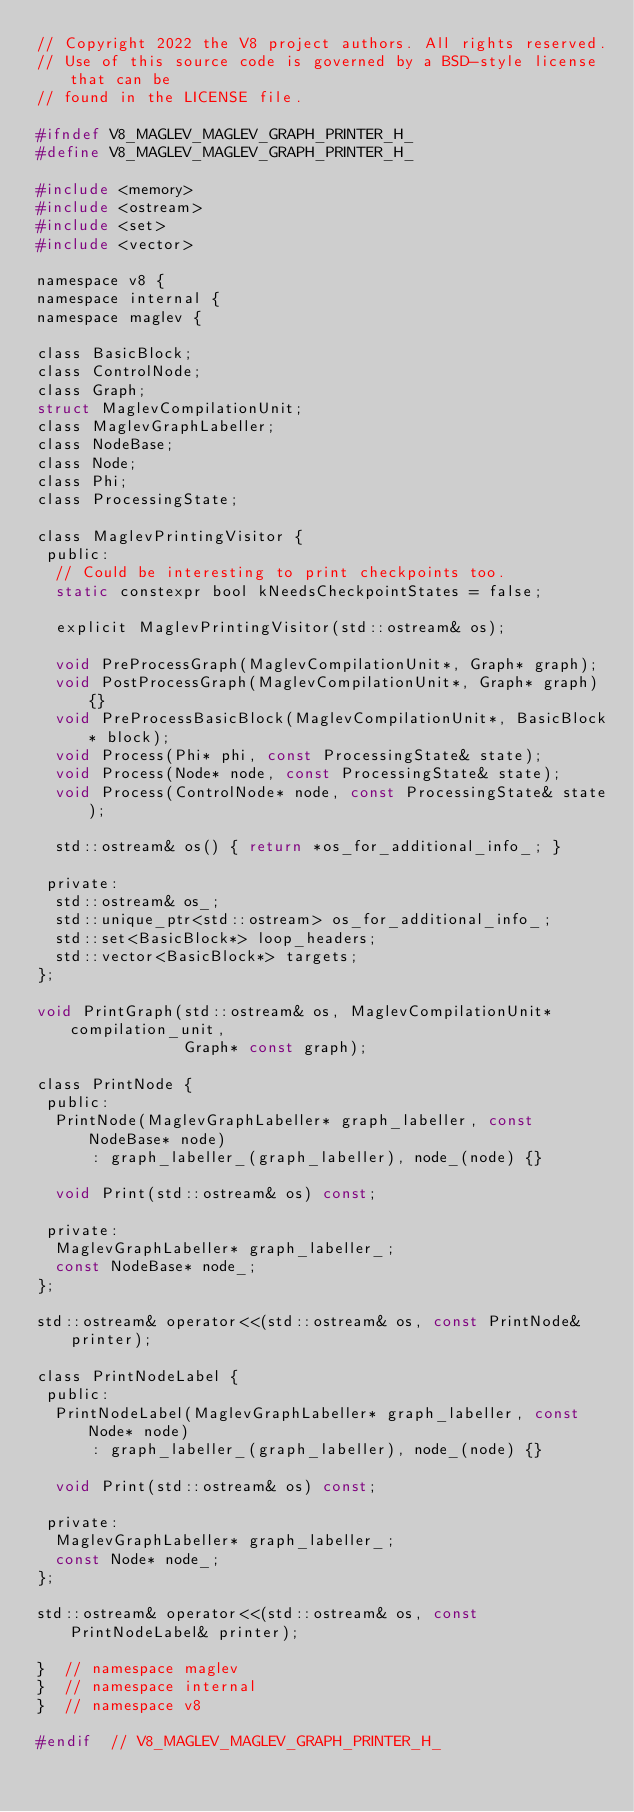<code> <loc_0><loc_0><loc_500><loc_500><_C_>// Copyright 2022 the V8 project authors. All rights reserved.
// Use of this source code is governed by a BSD-style license that can be
// found in the LICENSE file.

#ifndef V8_MAGLEV_MAGLEV_GRAPH_PRINTER_H_
#define V8_MAGLEV_MAGLEV_GRAPH_PRINTER_H_

#include <memory>
#include <ostream>
#include <set>
#include <vector>

namespace v8 {
namespace internal {
namespace maglev {

class BasicBlock;
class ControlNode;
class Graph;
struct MaglevCompilationUnit;
class MaglevGraphLabeller;
class NodeBase;
class Node;
class Phi;
class ProcessingState;

class MaglevPrintingVisitor {
 public:
  // Could be interesting to print checkpoints too.
  static constexpr bool kNeedsCheckpointStates = false;

  explicit MaglevPrintingVisitor(std::ostream& os);

  void PreProcessGraph(MaglevCompilationUnit*, Graph* graph);
  void PostProcessGraph(MaglevCompilationUnit*, Graph* graph) {}
  void PreProcessBasicBlock(MaglevCompilationUnit*, BasicBlock* block);
  void Process(Phi* phi, const ProcessingState& state);
  void Process(Node* node, const ProcessingState& state);
  void Process(ControlNode* node, const ProcessingState& state);

  std::ostream& os() { return *os_for_additional_info_; }

 private:
  std::ostream& os_;
  std::unique_ptr<std::ostream> os_for_additional_info_;
  std::set<BasicBlock*> loop_headers;
  std::vector<BasicBlock*> targets;
};

void PrintGraph(std::ostream& os, MaglevCompilationUnit* compilation_unit,
                Graph* const graph);

class PrintNode {
 public:
  PrintNode(MaglevGraphLabeller* graph_labeller, const NodeBase* node)
      : graph_labeller_(graph_labeller), node_(node) {}

  void Print(std::ostream& os) const;

 private:
  MaglevGraphLabeller* graph_labeller_;
  const NodeBase* node_;
};

std::ostream& operator<<(std::ostream& os, const PrintNode& printer);

class PrintNodeLabel {
 public:
  PrintNodeLabel(MaglevGraphLabeller* graph_labeller, const Node* node)
      : graph_labeller_(graph_labeller), node_(node) {}

  void Print(std::ostream& os) const;

 private:
  MaglevGraphLabeller* graph_labeller_;
  const Node* node_;
};

std::ostream& operator<<(std::ostream& os, const PrintNodeLabel& printer);

}  // namespace maglev
}  // namespace internal
}  // namespace v8

#endif  // V8_MAGLEV_MAGLEV_GRAPH_PRINTER_H_
</code> 